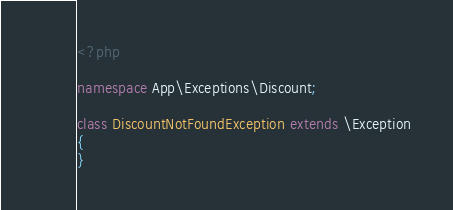Convert code to text. <code><loc_0><loc_0><loc_500><loc_500><_PHP_><?php

namespace App\Exceptions\Discount;

class DiscountNotFoundException extends \Exception
{
}
</code> 